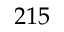<formula> <loc_0><loc_0><loc_500><loc_500>2 1 5</formula> 